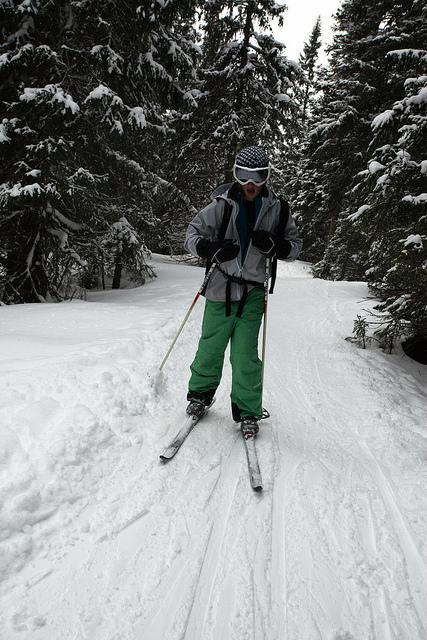How many people (in front and focus of the photo) have no birds on their shoulders?
Give a very brief answer. 0. 